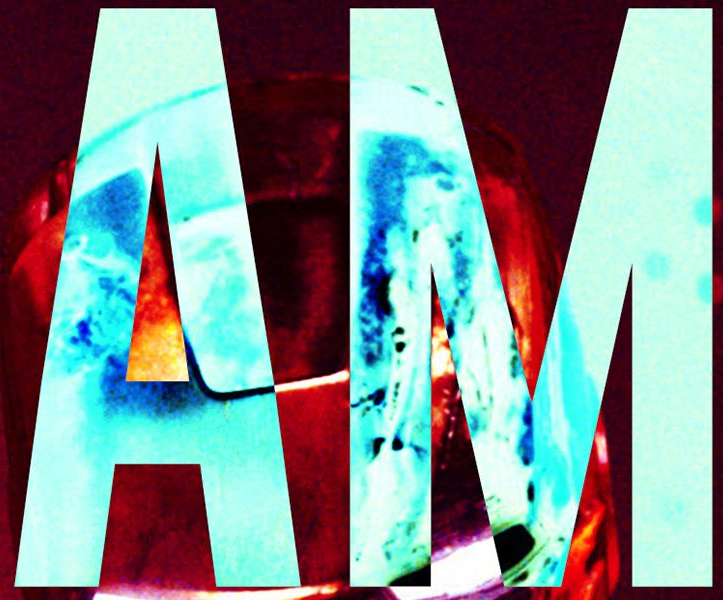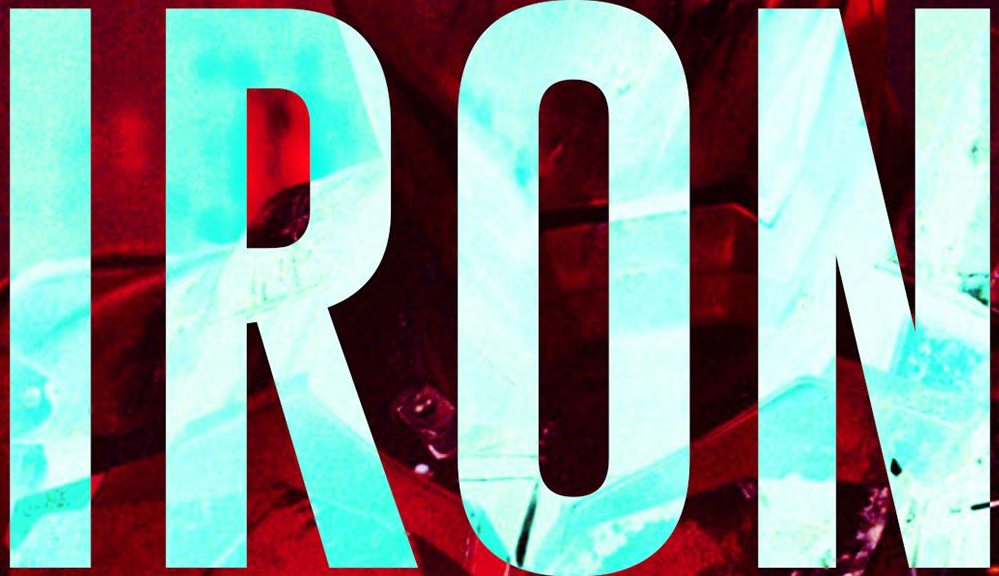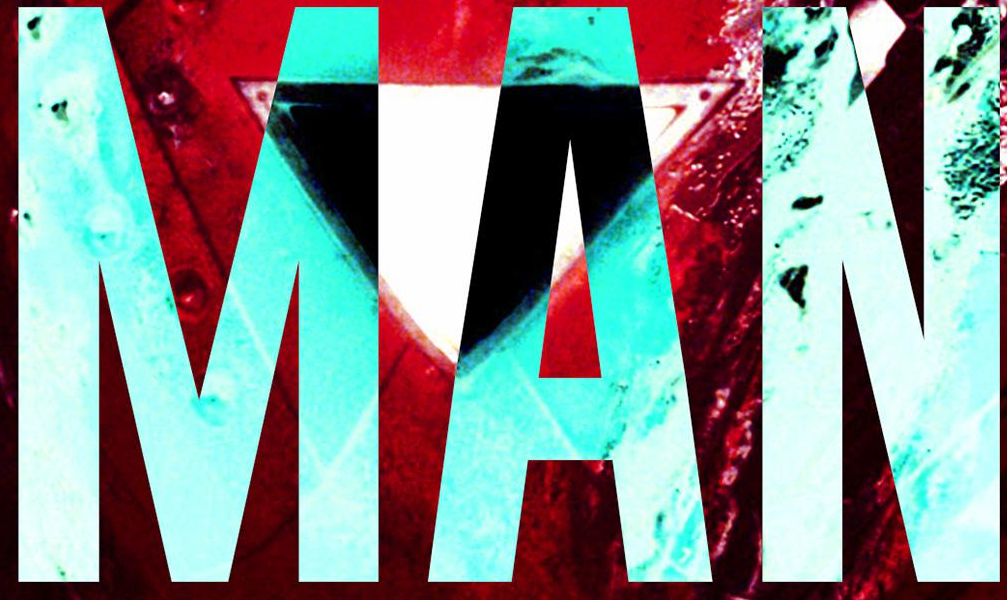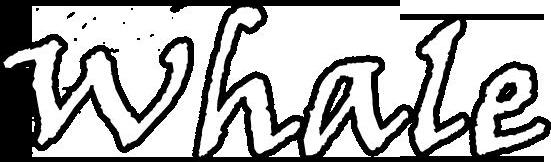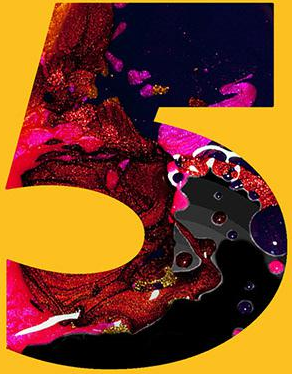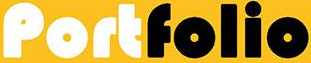What text appears in these images from left to right, separated by a semicolon? AM; IRON; MAN; whale; 5; Portfolio 